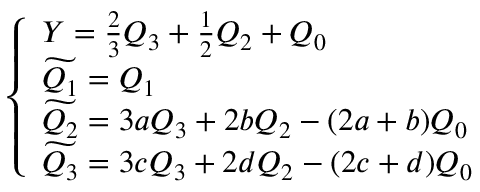Convert formula to latex. <formula><loc_0><loc_0><loc_500><loc_500>\left \{ \begin{array} { l } { { Y = \frac { 2 } { 3 } Q _ { 3 } + \frac { 1 } { 2 } Q _ { 2 } + Q _ { 0 } } } \\ { { \widetilde { Q _ { 1 } } = Q _ { 1 } } } \\ { { \widetilde { Q _ { 2 } } = 3 a Q _ { 3 } + 2 b Q _ { 2 } - ( 2 a + b ) Q _ { 0 } } } \\ { { \widetilde { Q _ { 3 } } = 3 c Q _ { 3 } + 2 d Q _ { 2 } - ( 2 c + d ) Q _ { 0 } } } \end{array}</formula> 